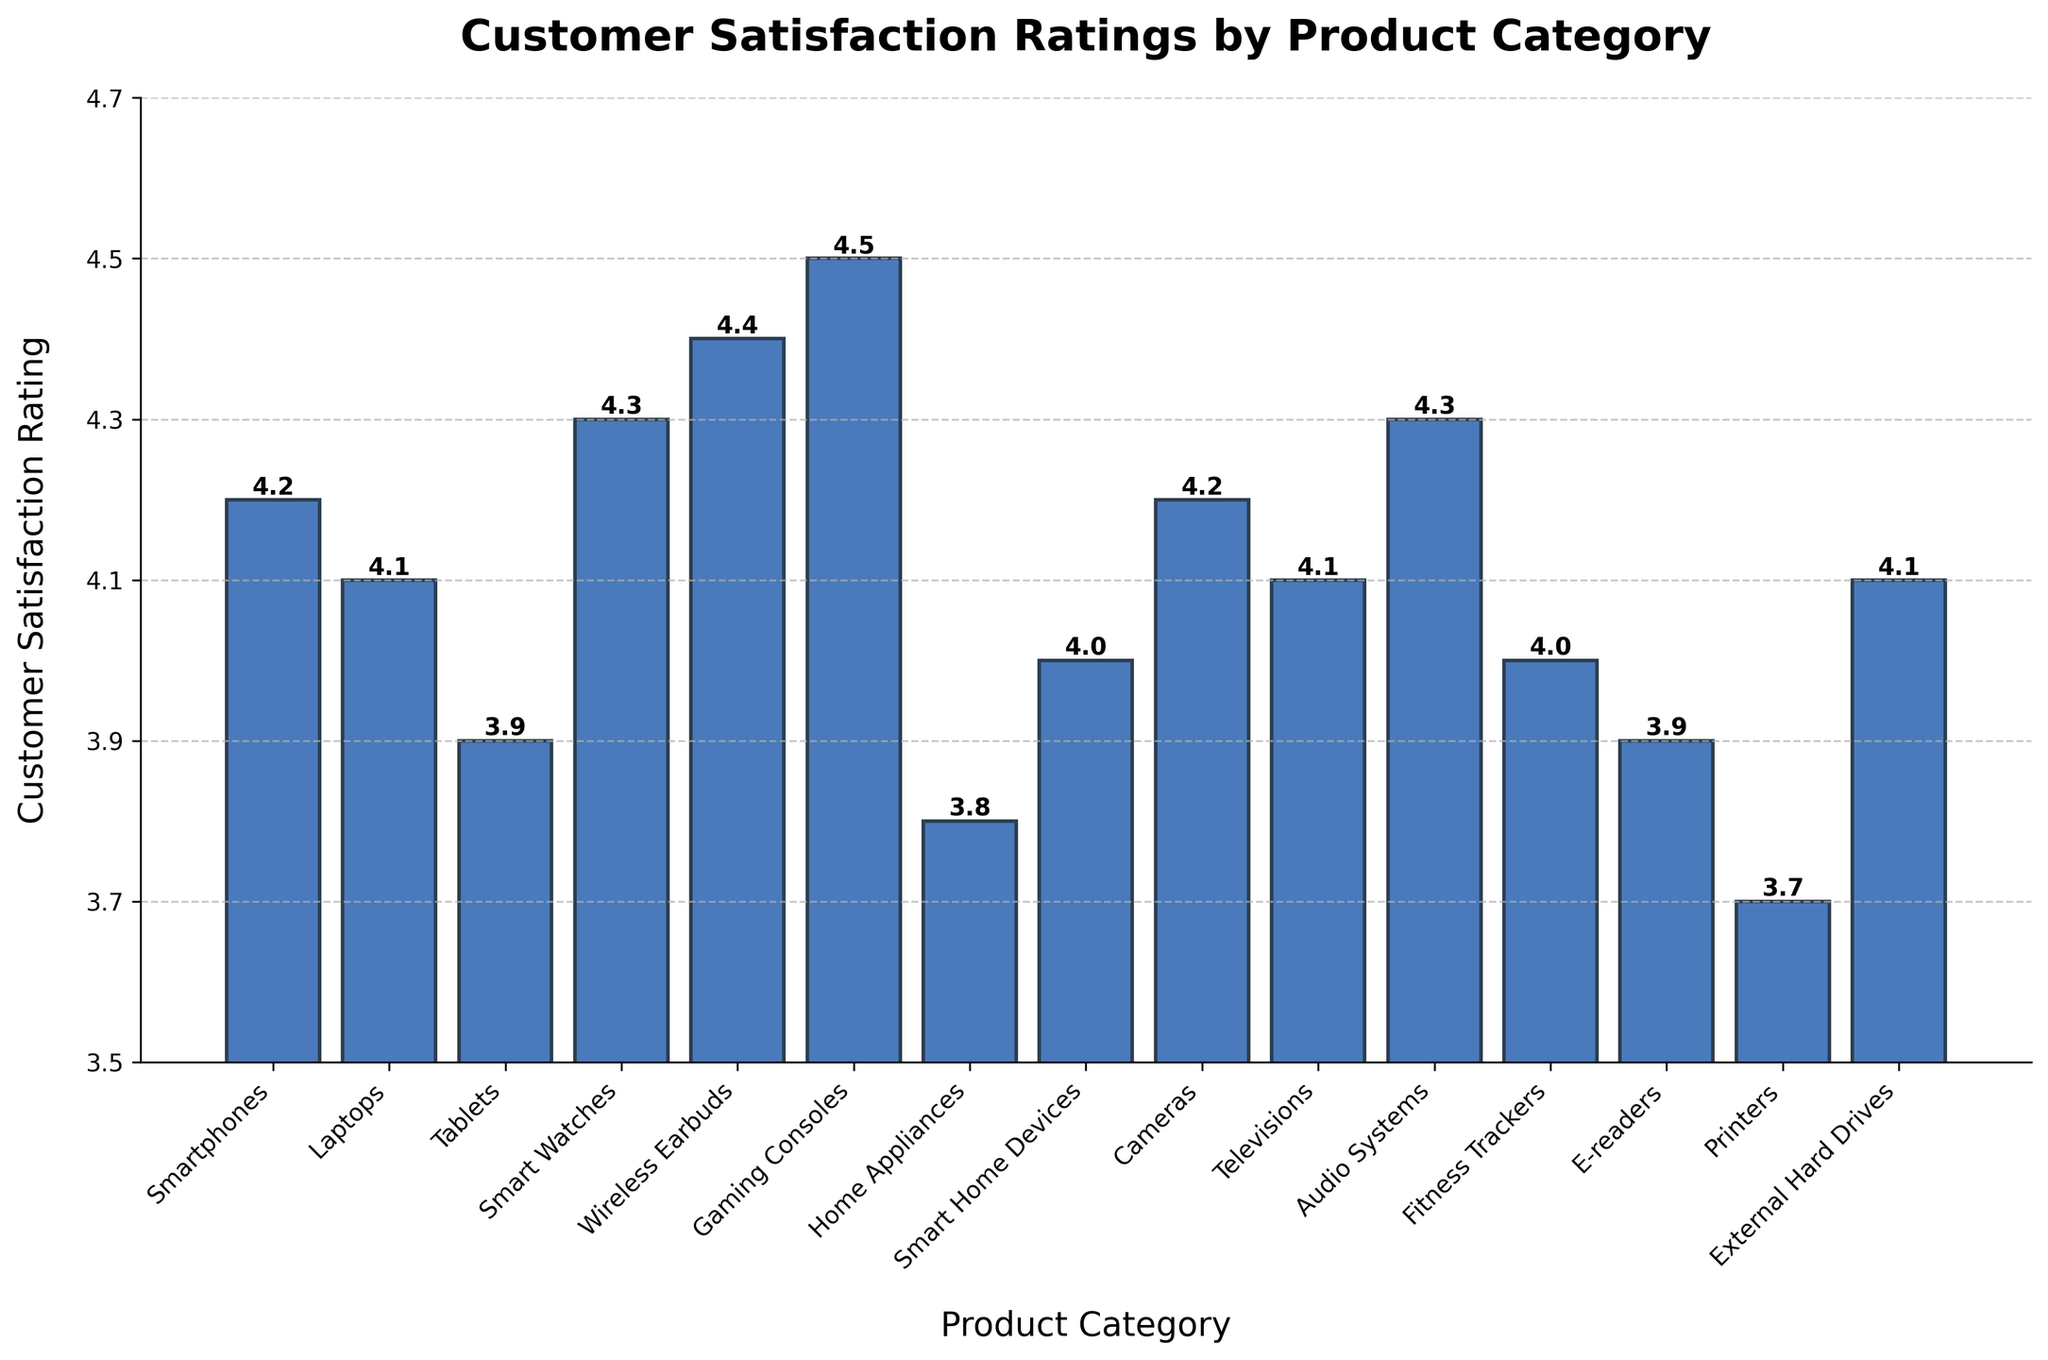What is the highest customer satisfaction rating among the product categories? To determine the highest customer satisfaction rating, look at the tallest bar on the chart. The height of this bar corresponds to the highest rating value.
Answer: 4.5 Which product category has the lowest customer satisfaction rating? Identify the shortest bar on the chart as it represents the lowest rating.
Answer: Printers How do the customer satisfaction ratings of Smart Watches and Wireless Earbuds compare? Observe the height of the bars for both categories. Wireless Earbuds has a rating of 4.4, which is slightly higher than Smart Watches at 4.3.
Answer: Wireless Earbuds > Smart Watches What is the difference in customer satisfaction ratings between Gaming Consoles and Home Appliances? Subtract the rating of Home Appliances from that of Gaming Consoles: 4.5 - 3.8. The difference is 0.7.
Answer: 0.7 Which product categories have a satisfaction rating equal to 4.1? Locate all bars with a height corresponding to the rating of 4.1. These are Laptops, Televisions, and External Hard Drives.
Answer: Laptops, Televisions, External Hard Drives What is the average customer satisfaction rating for Tablets, E-readers, and Printers? Sum the ratings (3.9 for Tablets, 3.9 for E-readers, 3.7 for Printers) and divide by the number of categories (3): (3.9 + 3.9 + 3.7) / 3 = 3.83.
Answer: 3.83 How many product categories have a customer satisfaction rating of 4.0 or above? Count all bars with height values of 4.0 or higher. There are 10 such categories.
Answer: 10 Are there any product categories with the same customer satisfaction rating of 4.2? If so, which ones? Look for bars with the same height corresponding to a rating of 4.2. Smartphones and Cameras both have a rating of 4.2.
Answer: Smartphones, Cameras How does the customer satisfaction rating of Smart Home Devices compare to the average rating of all product categories? First, calculate the average rating of all categories: (Sum of all ratings) / 15. Then compare this to the rating of Smart Home Devices, which is 4.0.
Answer: Smart Home Devices is slightly below average Which product category shows the closest customer satisfaction rating to the median rating of all categories? First, list all ratings in ascending order and find the median (middle value) of the sorted list. Identify the category with this median value.
Answer: External Hard Drives (median is around 4.1) 